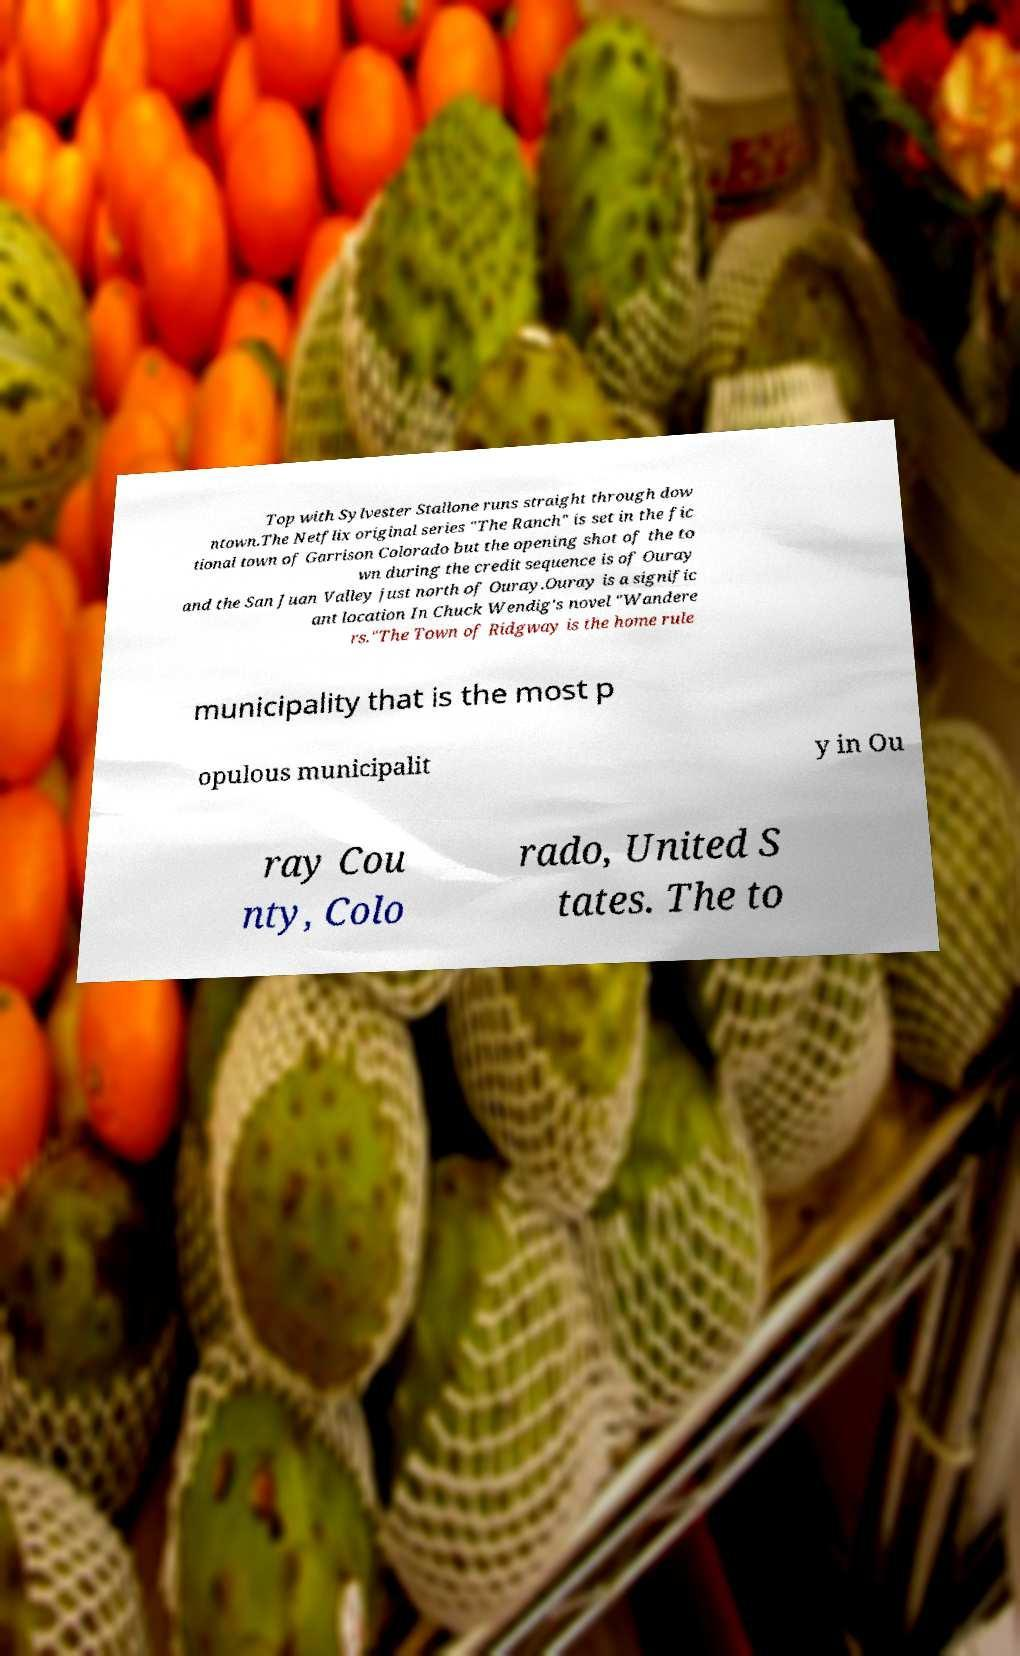Please identify and transcribe the text found in this image. Top with Sylvester Stallone runs straight through dow ntown.The Netflix original series "The Ranch" is set in the fic tional town of Garrison Colorado but the opening shot of the to wn during the credit sequence is of Ouray and the San Juan Valley just north of Ouray.Ouray is a signific ant location In Chuck Wendig's novel "Wandere rs."The Town of Ridgway is the home rule municipality that is the most p opulous municipalit y in Ou ray Cou nty, Colo rado, United S tates. The to 